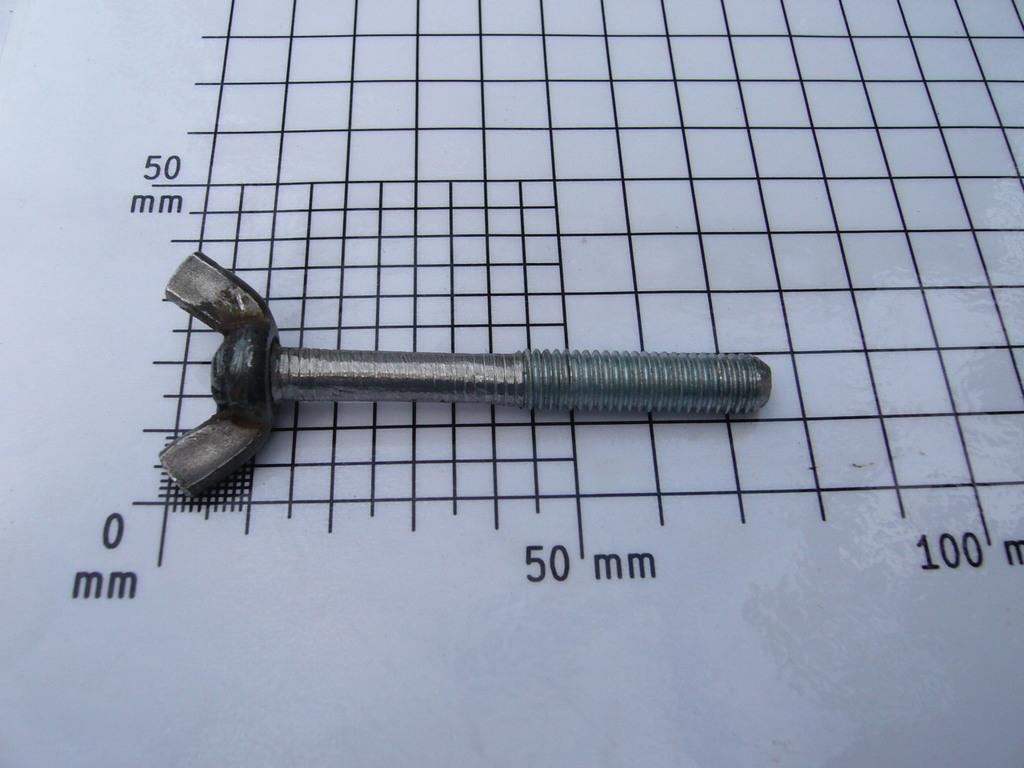<image>
Describe the image concisely. A screw sits on a grid that measures over 50 mm. 